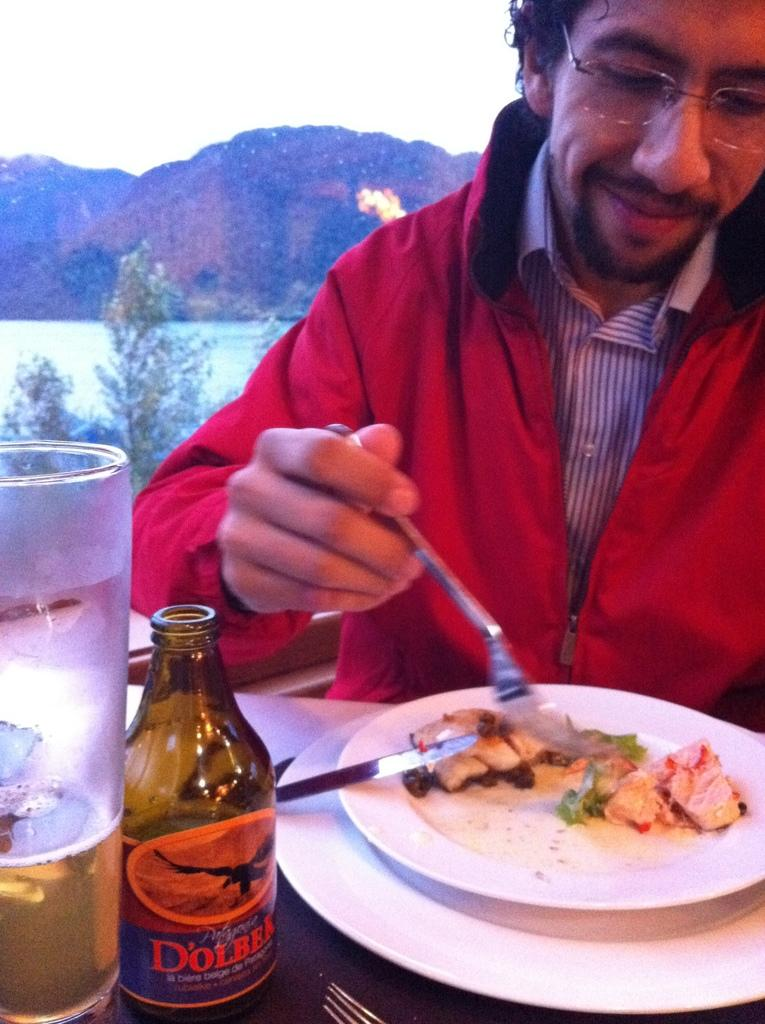Who is the person in the image? There is a man in the image. What is the man doing in the image? The man is eating food on a plate. Where is the plate located in the image? The plate is on a table. What is the man drinking from in the image? There is a glass in front of the man. What can be seen in the distance in the image? There is a mountain visible in the background of the image. What type of cabbage is being served in the middle of the table in the image? There is no cabbage present in the image; the man is eating food from a plate, but the specific food is not mentioned. 